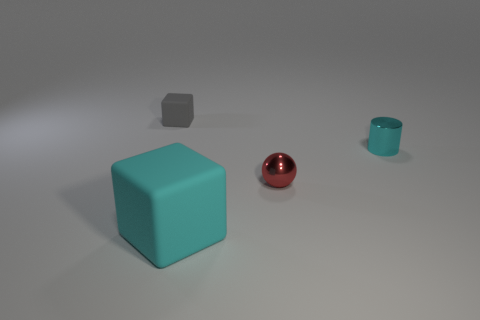How many other objects are the same size as the cyan rubber block?
Give a very brief answer. 0. Are there any other things that are the same color as the big block?
Your response must be concise. Yes. What number of cubes are either tiny cyan things or matte objects?
Make the answer very short. 2. What number of things are both left of the cyan shiny cylinder and to the right of the large rubber thing?
Keep it short and to the point. 1. Is the number of blocks that are in front of the cyan rubber object the same as the number of large matte objects on the right side of the small ball?
Offer a terse response. Yes. Do the metallic object in front of the tiny cyan cylinder and the small gray thing have the same shape?
Offer a very short reply. No. What shape is the rubber thing in front of the rubber block that is left of the cyan thing in front of the cylinder?
Your response must be concise. Cube. There is a matte thing that is the same color as the metal cylinder; what shape is it?
Your answer should be compact. Cube. There is a thing that is on the left side of the red shiny thing and in front of the small block; what material is it?
Ensure brevity in your answer.  Rubber. Is the number of large yellow cubes less than the number of tiny rubber objects?
Your answer should be very brief. Yes. 